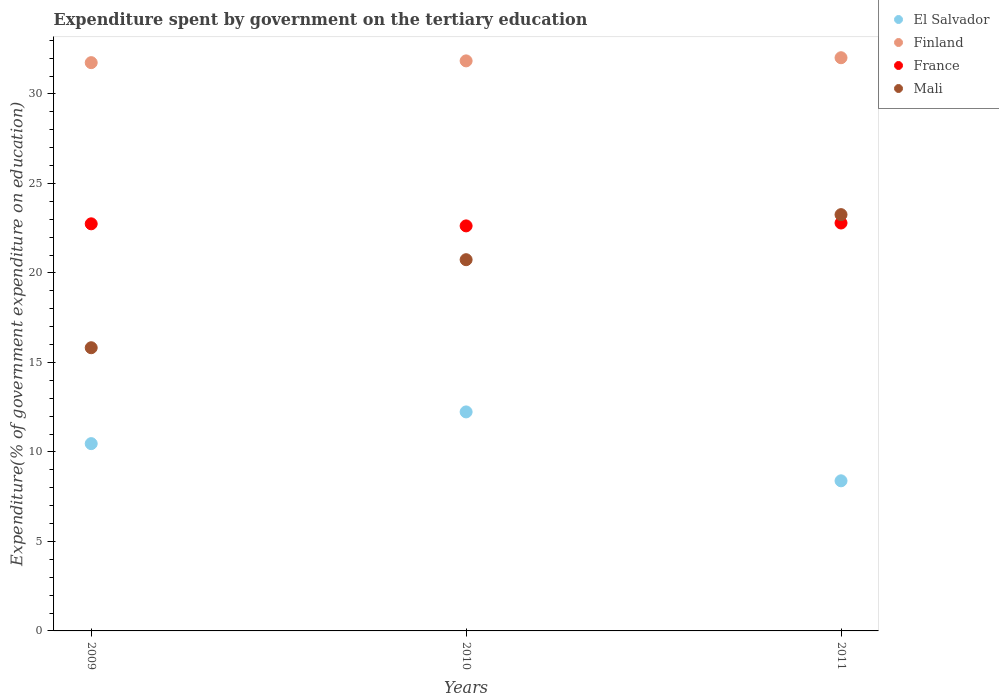What is the expenditure spent by government on the tertiary education in El Salvador in 2009?
Offer a very short reply. 10.46. Across all years, what is the maximum expenditure spent by government on the tertiary education in Mali?
Your response must be concise. 23.26. Across all years, what is the minimum expenditure spent by government on the tertiary education in Mali?
Make the answer very short. 15.82. In which year was the expenditure spent by government on the tertiary education in Mali maximum?
Ensure brevity in your answer.  2011. What is the total expenditure spent by government on the tertiary education in France in the graph?
Your response must be concise. 68.16. What is the difference between the expenditure spent by government on the tertiary education in France in 2009 and that in 2010?
Ensure brevity in your answer.  0.12. What is the difference between the expenditure spent by government on the tertiary education in Finland in 2011 and the expenditure spent by government on the tertiary education in El Salvador in 2009?
Your answer should be compact. 21.56. What is the average expenditure spent by government on the tertiary education in Finland per year?
Your answer should be compact. 31.87. In the year 2010, what is the difference between the expenditure spent by government on the tertiary education in France and expenditure spent by government on the tertiary education in Finland?
Provide a succinct answer. -9.22. What is the ratio of the expenditure spent by government on the tertiary education in Finland in 2009 to that in 2010?
Ensure brevity in your answer.  1. Is the expenditure spent by government on the tertiary education in Mali in 2010 less than that in 2011?
Your answer should be compact. Yes. Is the difference between the expenditure spent by government on the tertiary education in France in 2009 and 2010 greater than the difference between the expenditure spent by government on the tertiary education in Finland in 2009 and 2010?
Give a very brief answer. Yes. What is the difference between the highest and the second highest expenditure spent by government on the tertiary education in France?
Give a very brief answer. 0.05. What is the difference between the highest and the lowest expenditure spent by government on the tertiary education in El Salvador?
Your response must be concise. 3.85. In how many years, is the expenditure spent by government on the tertiary education in Finland greater than the average expenditure spent by government on the tertiary education in Finland taken over all years?
Make the answer very short. 1. Is the expenditure spent by government on the tertiary education in Mali strictly greater than the expenditure spent by government on the tertiary education in El Salvador over the years?
Keep it short and to the point. Yes. Is the expenditure spent by government on the tertiary education in Finland strictly less than the expenditure spent by government on the tertiary education in Mali over the years?
Provide a succinct answer. No. How many dotlines are there?
Make the answer very short. 4. Are the values on the major ticks of Y-axis written in scientific E-notation?
Give a very brief answer. No. Does the graph contain any zero values?
Your answer should be very brief. No. Where does the legend appear in the graph?
Provide a succinct answer. Top right. How are the legend labels stacked?
Offer a terse response. Vertical. What is the title of the graph?
Ensure brevity in your answer.  Expenditure spent by government on the tertiary education. What is the label or title of the Y-axis?
Offer a terse response. Expenditure(% of government expenditure on education). What is the Expenditure(% of government expenditure on education) of El Salvador in 2009?
Make the answer very short. 10.46. What is the Expenditure(% of government expenditure on education) in Finland in 2009?
Keep it short and to the point. 31.75. What is the Expenditure(% of government expenditure on education) of France in 2009?
Your answer should be very brief. 22.74. What is the Expenditure(% of government expenditure on education) in Mali in 2009?
Provide a short and direct response. 15.82. What is the Expenditure(% of government expenditure on education) of El Salvador in 2010?
Keep it short and to the point. 12.24. What is the Expenditure(% of government expenditure on education) of Finland in 2010?
Provide a succinct answer. 31.85. What is the Expenditure(% of government expenditure on education) in France in 2010?
Give a very brief answer. 22.63. What is the Expenditure(% of government expenditure on education) of Mali in 2010?
Your response must be concise. 20.74. What is the Expenditure(% of government expenditure on education) of El Salvador in 2011?
Provide a succinct answer. 8.39. What is the Expenditure(% of government expenditure on education) in Finland in 2011?
Keep it short and to the point. 32.02. What is the Expenditure(% of government expenditure on education) in France in 2011?
Your answer should be very brief. 22.79. What is the Expenditure(% of government expenditure on education) of Mali in 2011?
Your response must be concise. 23.26. Across all years, what is the maximum Expenditure(% of government expenditure on education) of El Salvador?
Give a very brief answer. 12.24. Across all years, what is the maximum Expenditure(% of government expenditure on education) in Finland?
Your answer should be compact. 32.02. Across all years, what is the maximum Expenditure(% of government expenditure on education) of France?
Provide a succinct answer. 22.79. Across all years, what is the maximum Expenditure(% of government expenditure on education) in Mali?
Your answer should be compact. 23.26. Across all years, what is the minimum Expenditure(% of government expenditure on education) in El Salvador?
Your answer should be very brief. 8.39. Across all years, what is the minimum Expenditure(% of government expenditure on education) of Finland?
Make the answer very short. 31.75. Across all years, what is the minimum Expenditure(% of government expenditure on education) in France?
Ensure brevity in your answer.  22.63. Across all years, what is the minimum Expenditure(% of government expenditure on education) of Mali?
Your answer should be very brief. 15.82. What is the total Expenditure(% of government expenditure on education) in El Salvador in the graph?
Provide a succinct answer. 31.09. What is the total Expenditure(% of government expenditure on education) of Finland in the graph?
Your answer should be compact. 95.62. What is the total Expenditure(% of government expenditure on education) in France in the graph?
Your answer should be very brief. 68.16. What is the total Expenditure(% of government expenditure on education) of Mali in the graph?
Make the answer very short. 59.82. What is the difference between the Expenditure(% of government expenditure on education) of El Salvador in 2009 and that in 2010?
Provide a succinct answer. -1.77. What is the difference between the Expenditure(% of government expenditure on education) of Finland in 2009 and that in 2010?
Keep it short and to the point. -0.1. What is the difference between the Expenditure(% of government expenditure on education) in France in 2009 and that in 2010?
Provide a succinct answer. 0.12. What is the difference between the Expenditure(% of government expenditure on education) in Mali in 2009 and that in 2010?
Provide a short and direct response. -4.92. What is the difference between the Expenditure(% of government expenditure on education) of El Salvador in 2009 and that in 2011?
Ensure brevity in your answer.  2.08. What is the difference between the Expenditure(% of government expenditure on education) of Finland in 2009 and that in 2011?
Give a very brief answer. -0.27. What is the difference between the Expenditure(% of government expenditure on education) in France in 2009 and that in 2011?
Provide a short and direct response. -0.04. What is the difference between the Expenditure(% of government expenditure on education) of Mali in 2009 and that in 2011?
Your answer should be very brief. -7.44. What is the difference between the Expenditure(% of government expenditure on education) of El Salvador in 2010 and that in 2011?
Offer a terse response. 3.85. What is the difference between the Expenditure(% of government expenditure on education) in Finland in 2010 and that in 2011?
Your answer should be compact. -0.18. What is the difference between the Expenditure(% of government expenditure on education) in France in 2010 and that in 2011?
Ensure brevity in your answer.  -0.16. What is the difference between the Expenditure(% of government expenditure on education) of Mali in 2010 and that in 2011?
Provide a short and direct response. -2.52. What is the difference between the Expenditure(% of government expenditure on education) of El Salvador in 2009 and the Expenditure(% of government expenditure on education) of Finland in 2010?
Your response must be concise. -21.38. What is the difference between the Expenditure(% of government expenditure on education) in El Salvador in 2009 and the Expenditure(% of government expenditure on education) in France in 2010?
Your answer should be very brief. -12.16. What is the difference between the Expenditure(% of government expenditure on education) in El Salvador in 2009 and the Expenditure(% of government expenditure on education) in Mali in 2010?
Offer a very short reply. -10.28. What is the difference between the Expenditure(% of government expenditure on education) of Finland in 2009 and the Expenditure(% of government expenditure on education) of France in 2010?
Offer a terse response. 9.12. What is the difference between the Expenditure(% of government expenditure on education) in Finland in 2009 and the Expenditure(% of government expenditure on education) in Mali in 2010?
Offer a very short reply. 11.01. What is the difference between the Expenditure(% of government expenditure on education) in France in 2009 and the Expenditure(% of government expenditure on education) in Mali in 2010?
Ensure brevity in your answer.  2. What is the difference between the Expenditure(% of government expenditure on education) of El Salvador in 2009 and the Expenditure(% of government expenditure on education) of Finland in 2011?
Keep it short and to the point. -21.56. What is the difference between the Expenditure(% of government expenditure on education) of El Salvador in 2009 and the Expenditure(% of government expenditure on education) of France in 2011?
Give a very brief answer. -12.33. What is the difference between the Expenditure(% of government expenditure on education) in El Salvador in 2009 and the Expenditure(% of government expenditure on education) in Mali in 2011?
Offer a terse response. -12.79. What is the difference between the Expenditure(% of government expenditure on education) in Finland in 2009 and the Expenditure(% of government expenditure on education) in France in 2011?
Provide a short and direct response. 8.96. What is the difference between the Expenditure(% of government expenditure on education) of Finland in 2009 and the Expenditure(% of government expenditure on education) of Mali in 2011?
Offer a very short reply. 8.49. What is the difference between the Expenditure(% of government expenditure on education) of France in 2009 and the Expenditure(% of government expenditure on education) of Mali in 2011?
Offer a terse response. -0.51. What is the difference between the Expenditure(% of government expenditure on education) in El Salvador in 2010 and the Expenditure(% of government expenditure on education) in Finland in 2011?
Give a very brief answer. -19.79. What is the difference between the Expenditure(% of government expenditure on education) of El Salvador in 2010 and the Expenditure(% of government expenditure on education) of France in 2011?
Ensure brevity in your answer.  -10.55. What is the difference between the Expenditure(% of government expenditure on education) in El Salvador in 2010 and the Expenditure(% of government expenditure on education) in Mali in 2011?
Your response must be concise. -11.02. What is the difference between the Expenditure(% of government expenditure on education) of Finland in 2010 and the Expenditure(% of government expenditure on education) of France in 2011?
Offer a very short reply. 9.06. What is the difference between the Expenditure(% of government expenditure on education) of Finland in 2010 and the Expenditure(% of government expenditure on education) of Mali in 2011?
Offer a very short reply. 8.59. What is the difference between the Expenditure(% of government expenditure on education) of France in 2010 and the Expenditure(% of government expenditure on education) of Mali in 2011?
Provide a short and direct response. -0.63. What is the average Expenditure(% of government expenditure on education) in El Salvador per year?
Make the answer very short. 10.36. What is the average Expenditure(% of government expenditure on education) in Finland per year?
Make the answer very short. 31.87. What is the average Expenditure(% of government expenditure on education) in France per year?
Your answer should be very brief. 22.72. What is the average Expenditure(% of government expenditure on education) of Mali per year?
Your answer should be compact. 19.94. In the year 2009, what is the difference between the Expenditure(% of government expenditure on education) in El Salvador and Expenditure(% of government expenditure on education) in Finland?
Your answer should be compact. -21.29. In the year 2009, what is the difference between the Expenditure(% of government expenditure on education) of El Salvador and Expenditure(% of government expenditure on education) of France?
Your answer should be very brief. -12.28. In the year 2009, what is the difference between the Expenditure(% of government expenditure on education) in El Salvador and Expenditure(% of government expenditure on education) in Mali?
Ensure brevity in your answer.  -5.36. In the year 2009, what is the difference between the Expenditure(% of government expenditure on education) in Finland and Expenditure(% of government expenditure on education) in France?
Your response must be concise. 9. In the year 2009, what is the difference between the Expenditure(% of government expenditure on education) in Finland and Expenditure(% of government expenditure on education) in Mali?
Provide a short and direct response. 15.93. In the year 2009, what is the difference between the Expenditure(% of government expenditure on education) in France and Expenditure(% of government expenditure on education) in Mali?
Make the answer very short. 6.92. In the year 2010, what is the difference between the Expenditure(% of government expenditure on education) of El Salvador and Expenditure(% of government expenditure on education) of Finland?
Give a very brief answer. -19.61. In the year 2010, what is the difference between the Expenditure(% of government expenditure on education) in El Salvador and Expenditure(% of government expenditure on education) in France?
Provide a short and direct response. -10.39. In the year 2010, what is the difference between the Expenditure(% of government expenditure on education) of El Salvador and Expenditure(% of government expenditure on education) of Mali?
Your response must be concise. -8.5. In the year 2010, what is the difference between the Expenditure(% of government expenditure on education) of Finland and Expenditure(% of government expenditure on education) of France?
Your answer should be compact. 9.22. In the year 2010, what is the difference between the Expenditure(% of government expenditure on education) of Finland and Expenditure(% of government expenditure on education) of Mali?
Make the answer very short. 11.11. In the year 2010, what is the difference between the Expenditure(% of government expenditure on education) of France and Expenditure(% of government expenditure on education) of Mali?
Keep it short and to the point. 1.89. In the year 2011, what is the difference between the Expenditure(% of government expenditure on education) of El Salvador and Expenditure(% of government expenditure on education) of Finland?
Provide a succinct answer. -23.64. In the year 2011, what is the difference between the Expenditure(% of government expenditure on education) of El Salvador and Expenditure(% of government expenditure on education) of France?
Keep it short and to the point. -14.4. In the year 2011, what is the difference between the Expenditure(% of government expenditure on education) in El Salvador and Expenditure(% of government expenditure on education) in Mali?
Provide a short and direct response. -14.87. In the year 2011, what is the difference between the Expenditure(% of government expenditure on education) of Finland and Expenditure(% of government expenditure on education) of France?
Provide a short and direct response. 9.23. In the year 2011, what is the difference between the Expenditure(% of government expenditure on education) in Finland and Expenditure(% of government expenditure on education) in Mali?
Offer a very short reply. 8.77. In the year 2011, what is the difference between the Expenditure(% of government expenditure on education) in France and Expenditure(% of government expenditure on education) in Mali?
Give a very brief answer. -0.47. What is the ratio of the Expenditure(% of government expenditure on education) of El Salvador in 2009 to that in 2010?
Ensure brevity in your answer.  0.86. What is the ratio of the Expenditure(% of government expenditure on education) of Finland in 2009 to that in 2010?
Your response must be concise. 1. What is the ratio of the Expenditure(% of government expenditure on education) of France in 2009 to that in 2010?
Offer a terse response. 1.01. What is the ratio of the Expenditure(% of government expenditure on education) in Mali in 2009 to that in 2010?
Your answer should be compact. 0.76. What is the ratio of the Expenditure(% of government expenditure on education) in El Salvador in 2009 to that in 2011?
Provide a succinct answer. 1.25. What is the ratio of the Expenditure(% of government expenditure on education) of Finland in 2009 to that in 2011?
Provide a succinct answer. 0.99. What is the ratio of the Expenditure(% of government expenditure on education) in France in 2009 to that in 2011?
Your answer should be compact. 1. What is the ratio of the Expenditure(% of government expenditure on education) in Mali in 2009 to that in 2011?
Your response must be concise. 0.68. What is the ratio of the Expenditure(% of government expenditure on education) of El Salvador in 2010 to that in 2011?
Offer a terse response. 1.46. What is the ratio of the Expenditure(% of government expenditure on education) in Finland in 2010 to that in 2011?
Provide a short and direct response. 0.99. What is the ratio of the Expenditure(% of government expenditure on education) of France in 2010 to that in 2011?
Provide a succinct answer. 0.99. What is the ratio of the Expenditure(% of government expenditure on education) of Mali in 2010 to that in 2011?
Provide a short and direct response. 0.89. What is the difference between the highest and the second highest Expenditure(% of government expenditure on education) of El Salvador?
Make the answer very short. 1.77. What is the difference between the highest and the second highest Expenditure(% of government expenditure on education) in Finland?
Offer a very short reply. 0.18. What is the difference between the highest and the second highest Expenditure(% of government expenditure on education) of France?
Your answer should be compact. 0.04. What is the difference between the highest and the second highest Expenditure(% of government expenditure on education) of Mali?
Give a very brief answer. 2.52. What is the difference between the highest and the lowest Expenditure(% of government expenditure on education) of El Salvador?
Make the answer very short. 3.85. What is the difference between the highest and the lowest Expenditure(% of government expenditure on education) in Finland?
Your answer should be compact. 0.27. What is the difference between the highest and the lowest Expenditure(% of government expenditure on education) in France?
Your response must be concise. 0.16. What is the difference between the highest and the lowest Expenditure(% of government expenditure on education) in Mali?
Make the answer very short. 7.44. 